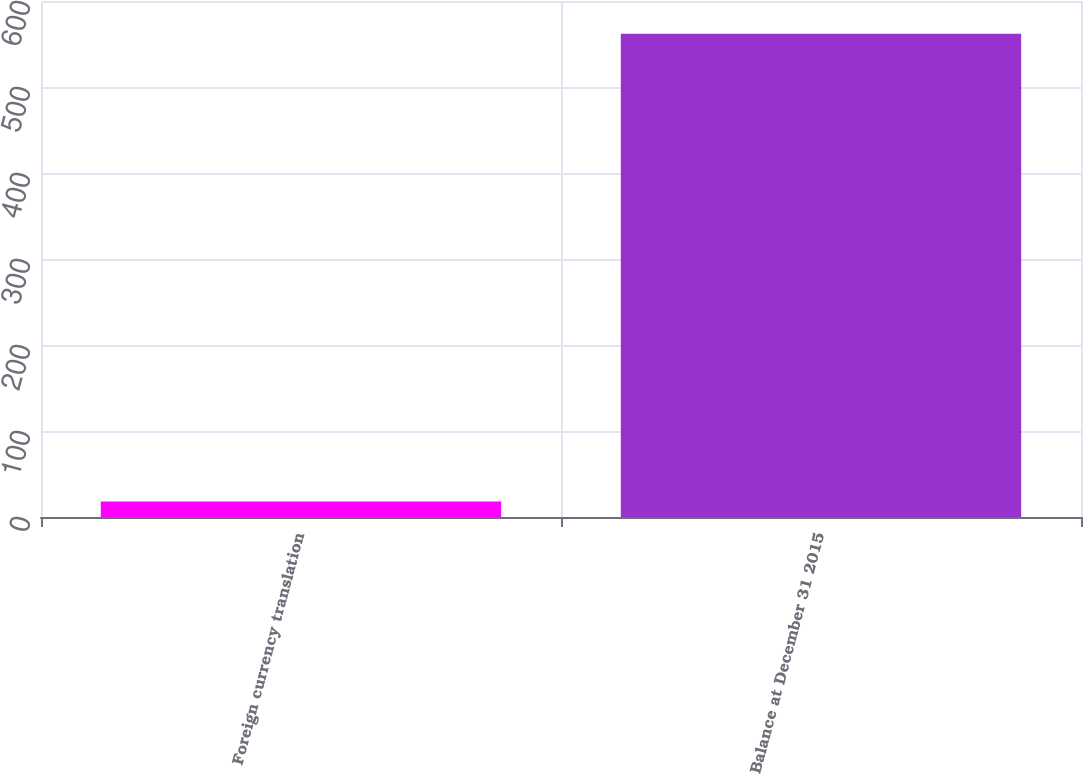<chart> <loc_0><loc_0><loc_500><loc_500><bar_chart><fcel>Foreign currency translation<fcel>Balance at December 31 2015<nl><fcel>18<fcel>562<nl></chart> 